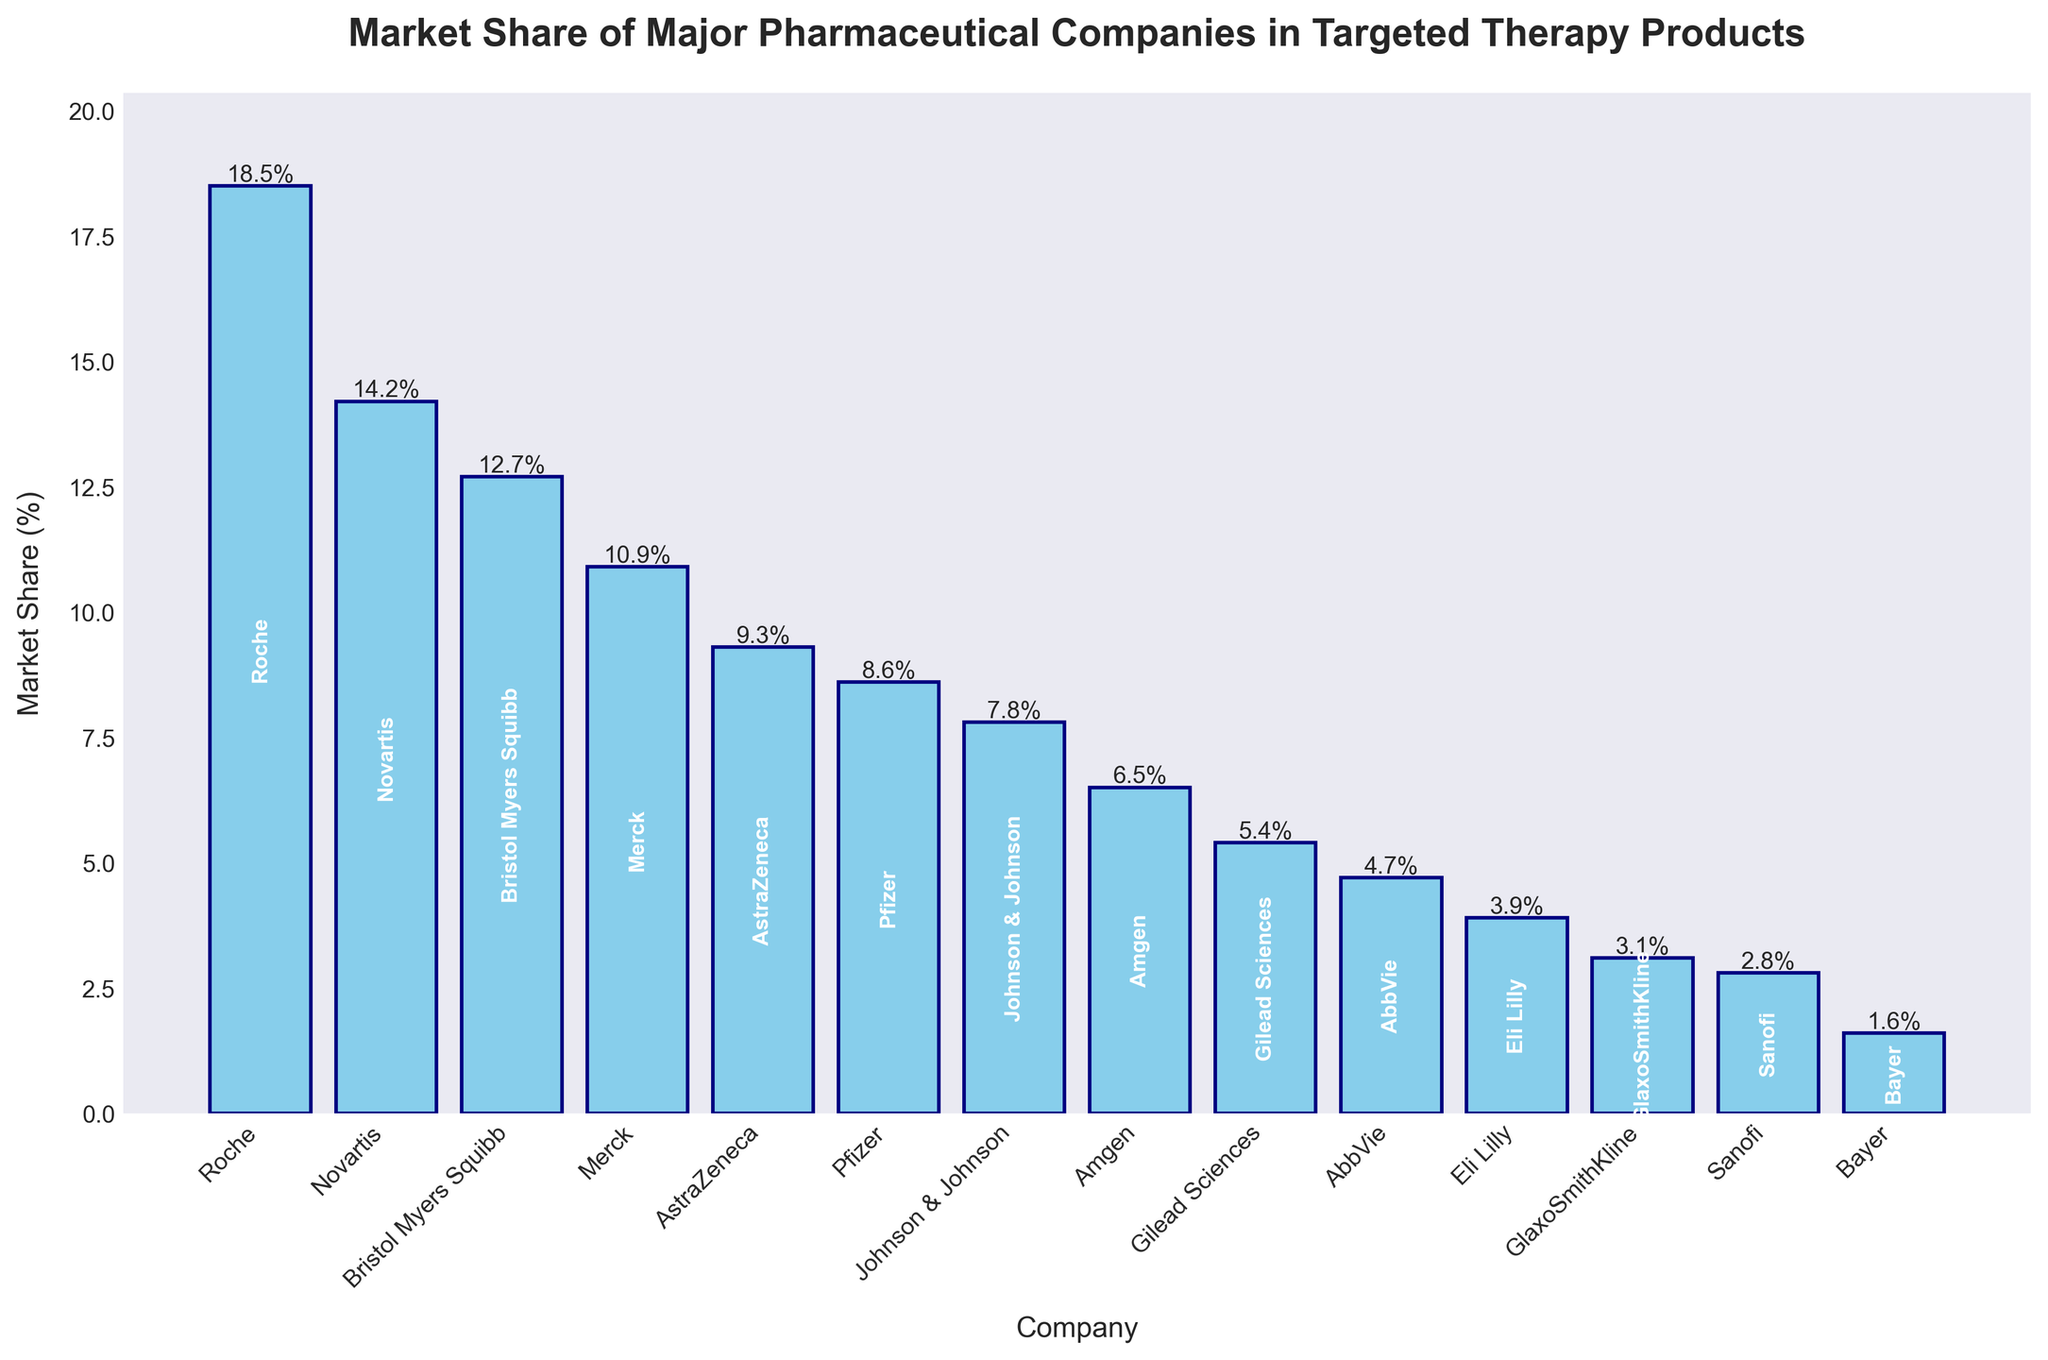Which company has the highest market share in targeted therapy products? By looking at the figure, the bar for Roche is the tallest among all companies, indicating the highest market share.
Answer: Roche How much greater is Roche's market share compared to Sanofi's? From the figure, Roche's market share is 18.5% and Sanofi's market share is 2.8%. The difference is calculated as 18.5 - 2.8 = 15.7.
Answer: 15.7% Which companies have a market share of more than 10%? According to the figure, Roche, Novartis, Bristol Myers Squibb, and Merck have their bars extending above the 10% mark.
Answer: Roche, Novartis, Bristol Myers Squibb, Merck What is the total market share of the top three companies? The top three companies by market share are Roche (18.5%), Novartis (14.2%), and Bristol Myers Squibb (12.7%). The total market share is 18.5 + 14.2 + 12.7 = 45.4.
Answer: 45.4% Compare the market shares of Pfizer and AstraZeneca. Which one is higher and by how much? The figure shows AstraZeneca's market share is 9.3% and Pfizer's is 8.6%. AstraZeneca's market share is higher. The difference is 9.3 - 8.6 = 0.7.
Answer: AstraZeneca by 0.7% What is the combined market share of companies with less than 5%? According to the figure, companies with less than 5% market share are AbbVie (4.7%), Eli Lilly (3.9%), GlaxoSmithKline (3.1%), Sanofi (2.8%), and Bayer (1.6%). Their combined market share is 4.7 + 3.9 + 3.1 + 2.8 + 1.6 = 16.1.
Answer: 16.1% What is the average market share of all companies listed? To find the average, sum all the market shares and divide by the number of companies. The total market share is 18.5 + 14.2 + 12.7 + 10.9 + 9.3 + 8.6 + 7.8 + 6.5 + 5.4 + 4.7 + 3.9 + 3.1 + 2.8 + 1.6 = 110. For 14 companies, the average is 110 / 14 ≈ 7.86.
Answer: 7.86% Which company has the smallest market share and what is the percentage? The figure shows the shortest bar belongs to Bayer with a market share of 1.6%, which is the smallest among all companies.
Answer: Bayer, 1.6% What is the median market share? To find the median, list all market shares in ascending order: 1.6, 2.8, 3.1, 3.9, 4.7, 5.4, 6.5, 7.8, 8.6, 9.3, 10.9, 12.7, 14.2, 18.5. Since there are 14 values, take the average of the 7th and 8th values: (6.5 + 7.8) / 2 = 7.15.
Answer: 7.15% 